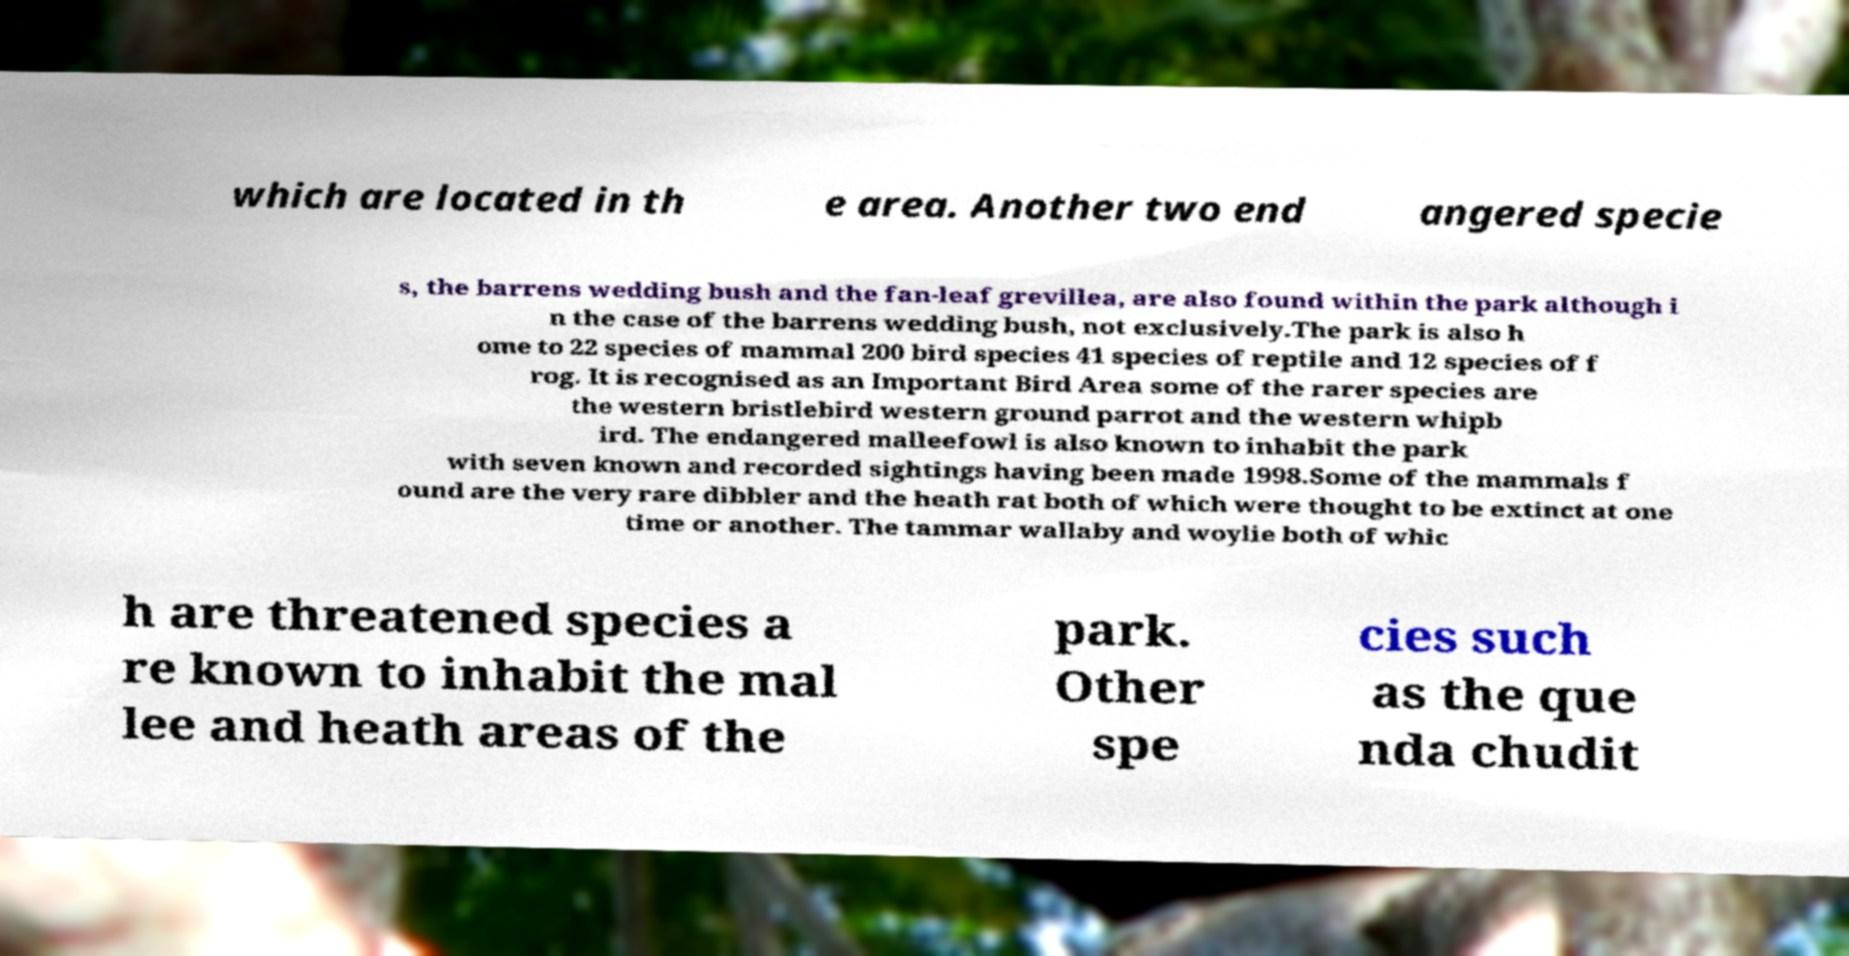There's text embedded in this image that I need extracted. Can you transcribe it verbatim? which are located in th e area. Another two end angered specie s, the barrens wedding bush and the fan-leaf grevillea, are also found within the park although i n the case of the barrens wedding bush, not exclusively.The park is also h ome to 22 species of mammal 200 bird species 41 species of reptile and 12 species of f rog. It is recognised as an Important Bird Area some of the rarer species are the western bristlebird western ground parrot and the western whipb ird. The endangered malleefowl is also known to inhabit the park with seven known and recorded sightings having been made 1998.Some of the mammals f ound are the very rare dibbler and the heath rat both of which were thought to be extinct at one time or another. The tammar wallaby and woylie both of whic h are threatened species a re known to inhabit the mal lee and heath areas of the park. Other spe cies such as the que nda chudit 